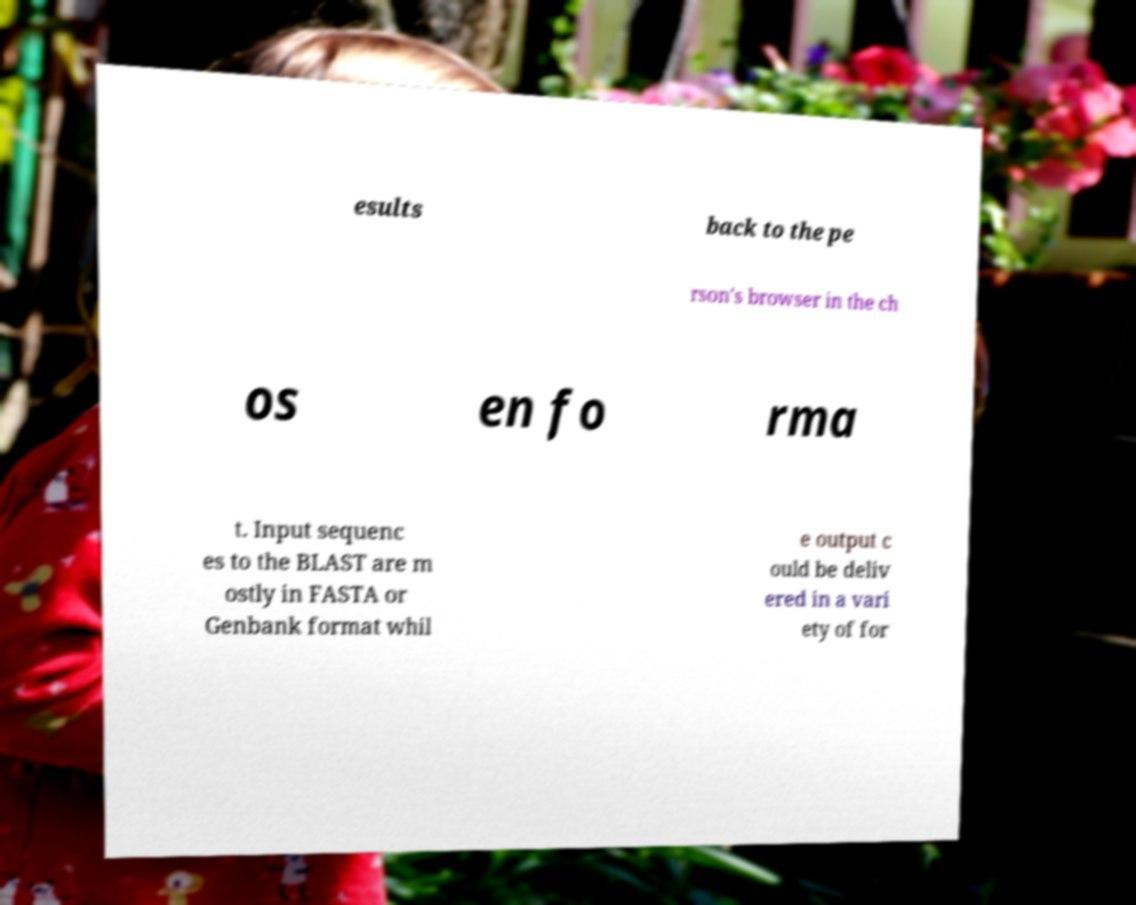Can you read and provide the text displayed in the image?This photo seems to have some interesting text. Can you extract and type it out for me? esults back to the pe rson's browser in the ch os en fo rma t. Input sequenc es to the BLAST are m ostly in FASTA or Genbank format whil e output c ould be deliv ered in a vari ety of for 